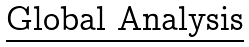Convert formula to latex. <formula><loc_0><loc_0><loc_500><loc_500>\text {\underline{Global Analysis}}</formula> 